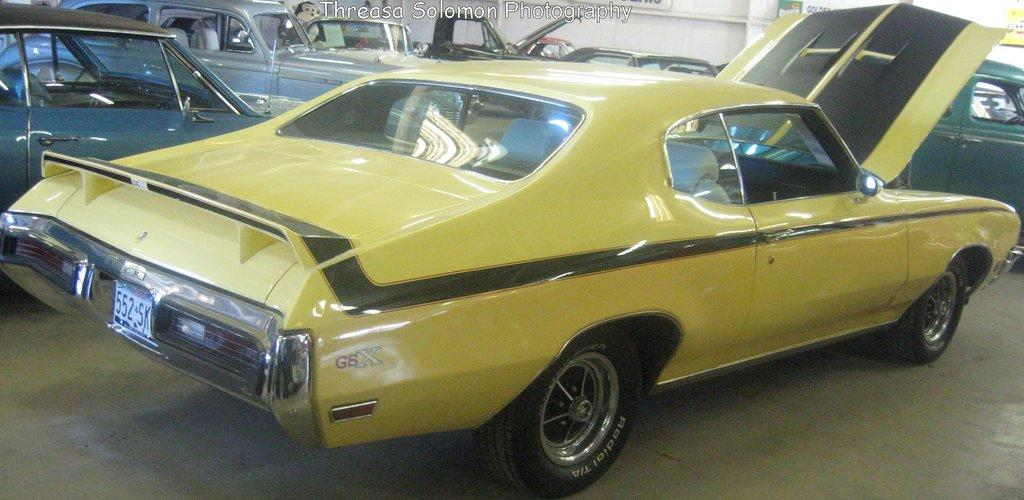What types of vehicles can be seen in the image? There are vehicles in different colors in the image. Where are the vehicles located? The vehicles are parked on the floor. What can be seen in the background of the image? There is a white wall in the background of the image. Is there any additional marking or feature on the image? Yes, there is a watermark in the image. How many feet are visible on the vehicles in the image? There are no visible feet on the vehicles in the image, as vehicles do not have feet. 